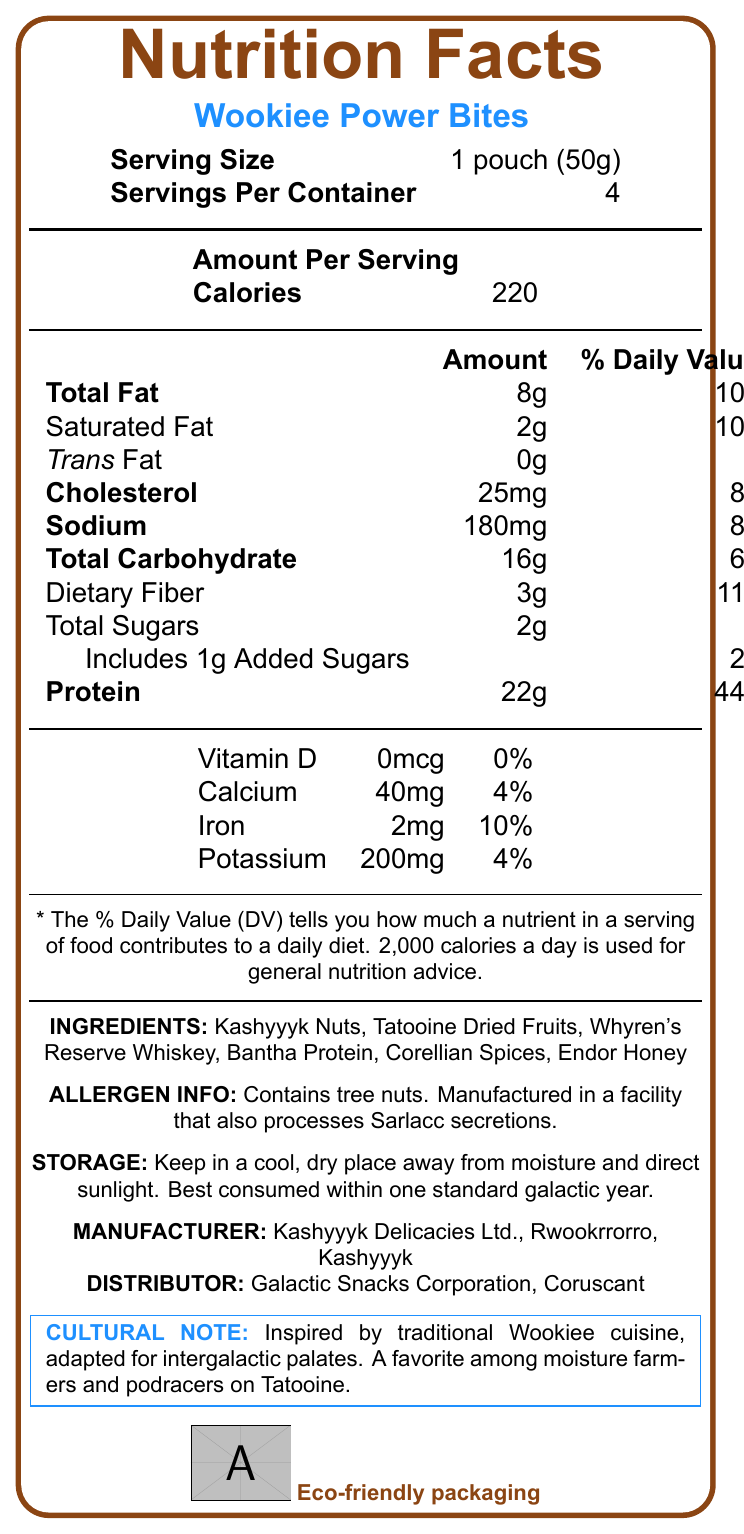How many servings are there per container? The document states that there are 4 servings per container in the "Serving Size" section at the top.
Answer: 4 What is the amount of protein in one serving? The document lists "Protein" as 22g per serving in the nutritional information section.
Answer: 22g Are Wookiee Power Bites suitable for vegans? The additional information section explicitly states that the product is not suitable for vegans.
Answer: No What is the primary ingredient of Wookiee Power Bites? The ingredients list begins with "Kashyyyk Nuts," indicating it is the primary ingredient.
Answer: Kashyyyk Nuts What is the daily value percentage of dietary fiber in one serving? The nutritional information specifies that one serving contains 11% of the daily value of dietary fiber.
Answer: 11% The Wookiee Power Bites contain trans fat. A. True B. False The document lists "Trans Fat" as 0g in the nutritional information section.
Answer: B. False How many calories are in one serving of Wookiee Power Bites? A. 150 B. 220 C. 180 D. 200 The document states that one serving contains 220 calories.
Answer: B. 220 What type of packaging is used for Wookiee Power Bites? A. Plastic B. Metal C. Biodegradable wrapper D. Glass The additional information section mentions that the packaging is a "biodegradable wrapper made from Kashyyyk tree fibers."
Answer: C. Biodegradable wrapper Does the product contain any allergens? The allergen information section states that the product contains tree nuts and is manufactured in a facility that processes Sarlacc secretions.
Answer: Yes Does the product have added sugars? The nutritional information lists 1g of added sugars per serving.
Answer: Yes Summarize the main idea of the document. The document includes sections on serving size, calories, nutritional content, ingredients, possible allergens, storage guidance, manufacturer and distributor details, and a note on the cultural inspiration behind the product.
Answer: The document provides detailed nutrition facts, ingredients, allergen information, storage instructions, manufacturer and distributor information, and cultural notes about Wookiee Power Bites, a high-protein snack. How should Wookiee Power Bites be stored? The storage instructions section specifies how to properly store the product to ensure it remains fresh.
Answer: In a cool, dry place away from moisture and direct sunlight. Best consumed within one standard galactic year. What is Whyren's Reserve Whiskey? The document does not provide any information about Whyren's Reserve Whiskey beyond it being listed as an ingredient.
Answer: Cannot be determined 